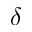Convert formula to latex. <formula><loc_0><loc_0><loc_500><loc_500>\delta</formula> 